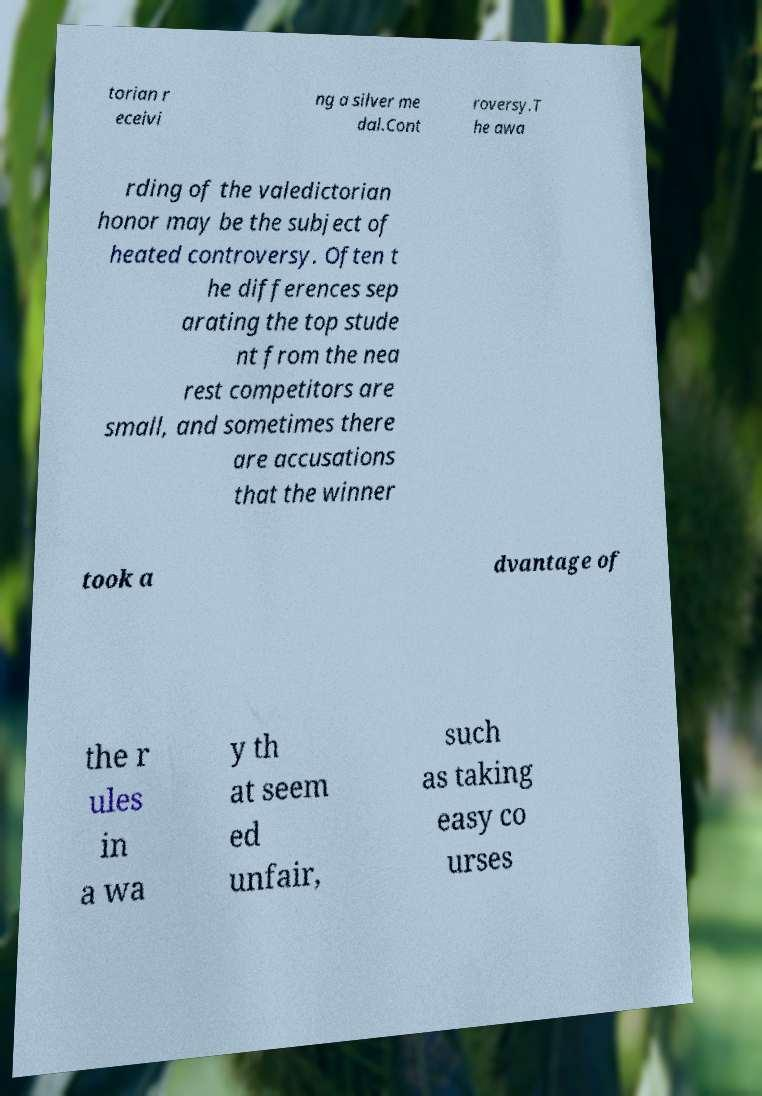Could you assist in decoding the text presented in this image and type it out clearly? torian r eceivi ng a silver me dal.Cont roversy.T he awa rding of the valedictorian honor may be the subject of heated controversy. Often t he differences sep arating the top stude nt from the nea rest competitors are small, and sometimes there are accusations that the winner took a dvantage of the r ules in a wa y th at seem ed unfair, such as taking easy co urses 